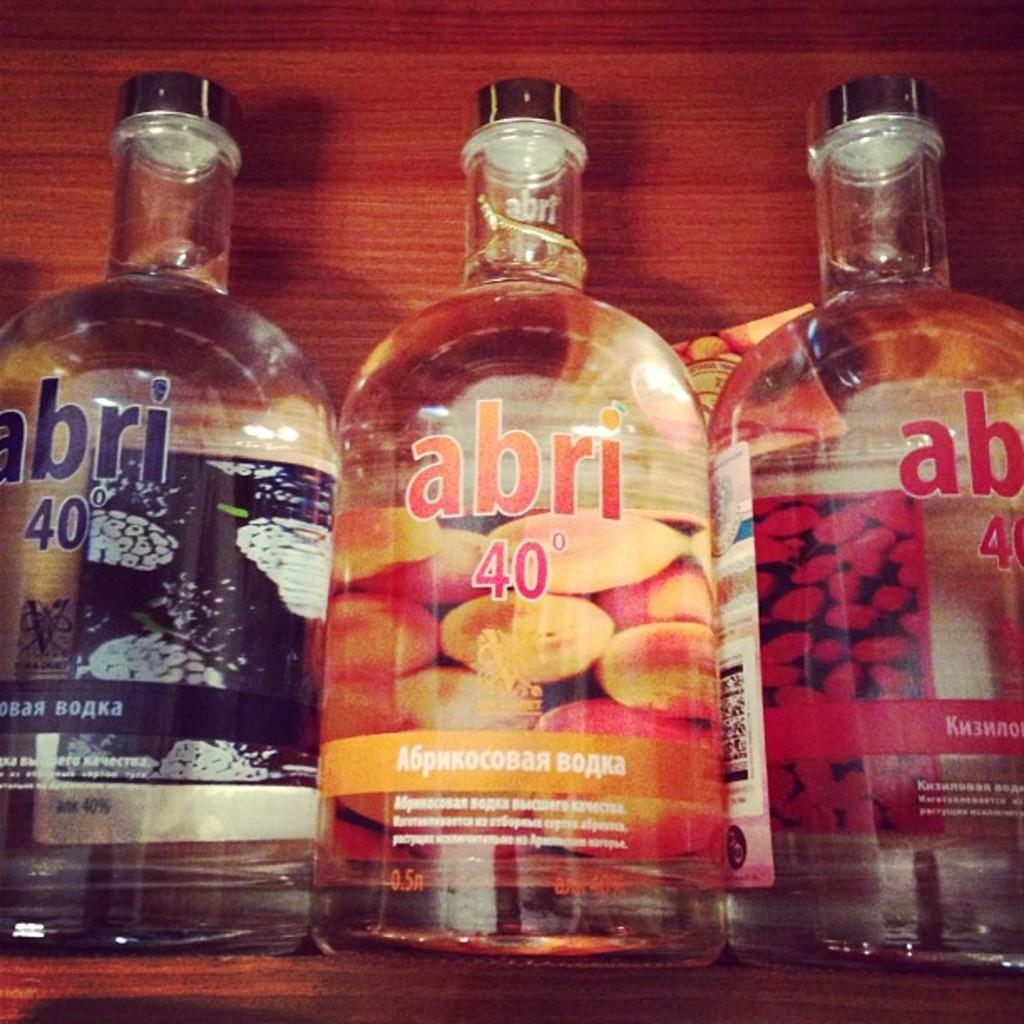<image>
Share a concise interpretation of the image provided. Bottles of Abri 40 are shown in different flavors. 